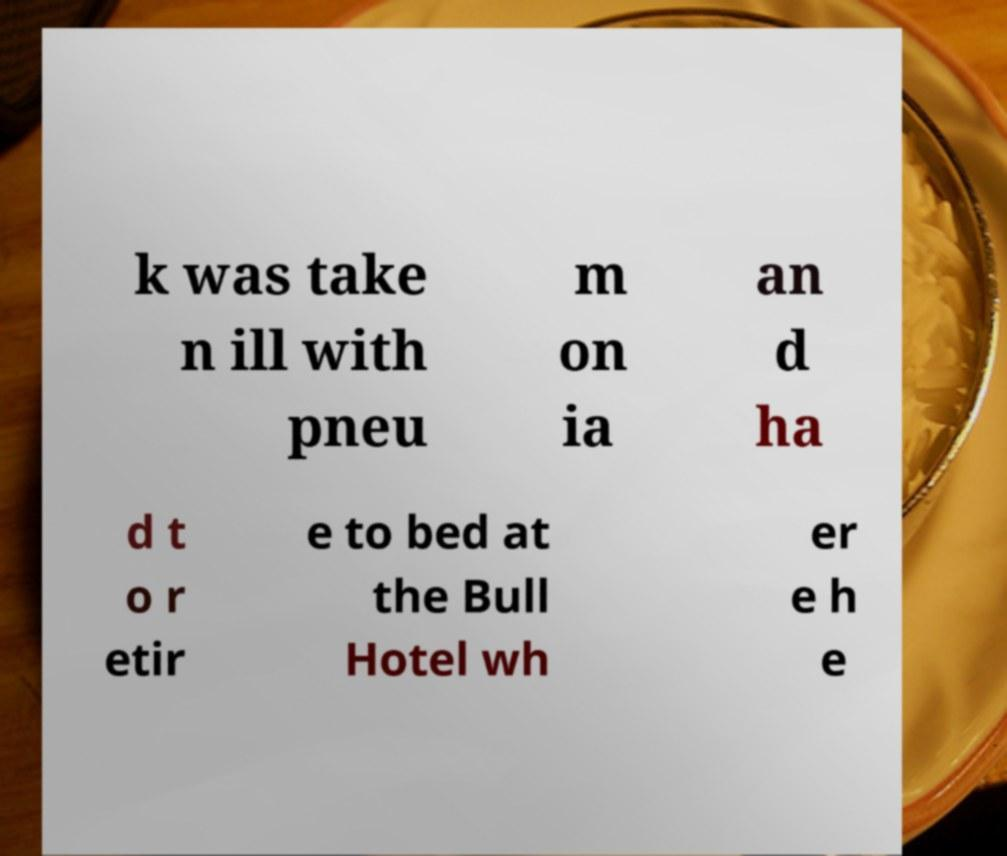Can you accurately transcribe the text from the provided image for me? k was take n ill with pneu m on ia an d ha d t o r etir e to bed at the Bull Hotel wh er e h e 